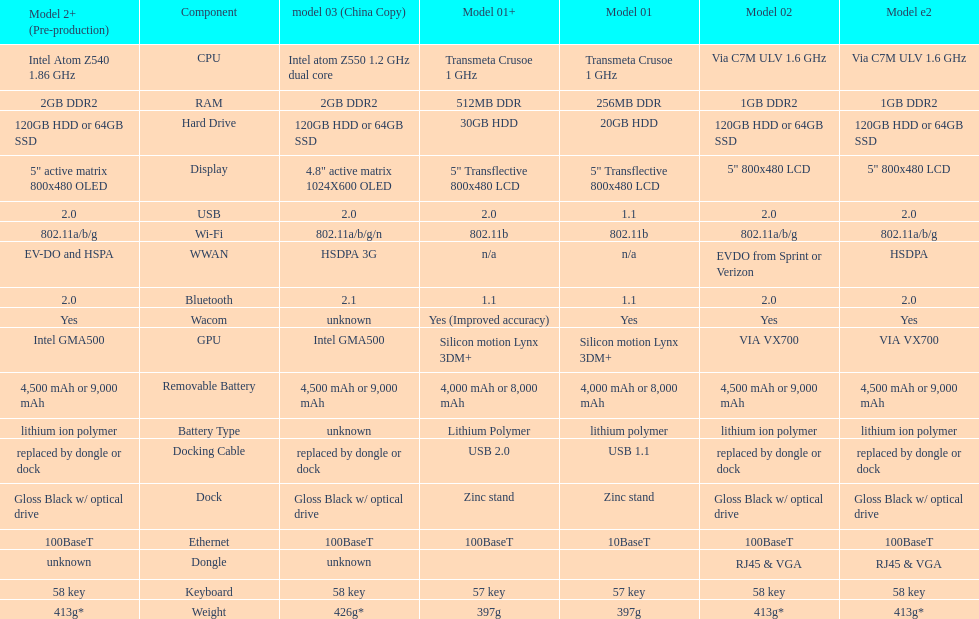What component comes after bluetooth? Wacom. 